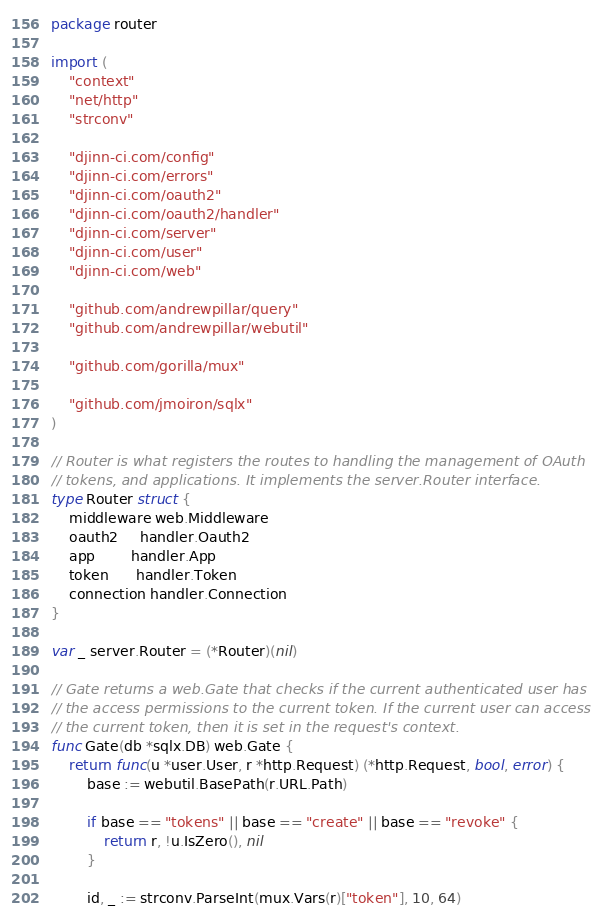Convert code to text. <code><loc_0><loc_0><loc_500><loc_500><_Go_>package router

import (
	"context"
	"net/http"
	"strconv"

	"djinn-ci.com/config"
	"djinn-ci.com/errors"
	"djinn-ci.com/oauth2"
	"djinn-ci.com/oauth2/handler"
	"djinn-ci.com/server"
	"djinn-ci.com/user"
	"djinn-ci.com/web"

	"github.com/andrewpillar/query"
	"github.com/andrewpillar/webutil"

	"github.com/gorilla/mux"

	"github.com/jmoiron/sqlx"
)

// Router is what registers the routes to handling the management of OAuth
// tokens, and applications. It implements the server.Router interface.
type Router struct {
	middleware web.Middleware
	oauth2     handler.Oauth2
	app        handler.App
	token      handler.Token
	connection handler.Connection
}

var _ server.Router = (*Router)(nil)

// Gate returns a web.Gate that checks if the current authenticated user has
// the access permissions to the current token. If the current user can access
// the current token, then it is set in the request's context.
func Gate(db *sqlx.DB) web.Gate {
	return func(u *user.User, r *http.Request) (*http.Request, bool, error) {
		base := webutil.BasePath(r.URL.Path)

		if base == "tokens" || base == "create" || base == "revoke" {
			return r, !u.IsZero(), nil
		}

		id, _ := strconv.ParseInt(mux.Vars(r)["token"], 10, 64)
</code> 